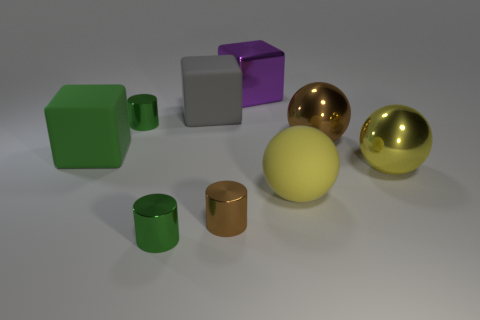Subtract all large purple metal cubes. How many cubes are left? 2 Subtract 2 blocks. How many blocks are left? 1 Subtract all purple blocks. How many blocks are left? 2 Subtract all cubes. How many objects are left? 6 Subtract all yellow spheres. Subtract all red cubes. How many spheres are left? 1 Subtract all yellow cylinders. How many yellow balls are left? 2 Subtract all yellow things. Subtract all tiny brown objects. How many objects are left? 6 Add 8 large purple blocks. How many large purple blocks are left? 9 Add 9 yellow shiny things. How many yellow shiny things exist? 10 Subtract 1 gray cubes. How many objects are left? 8 